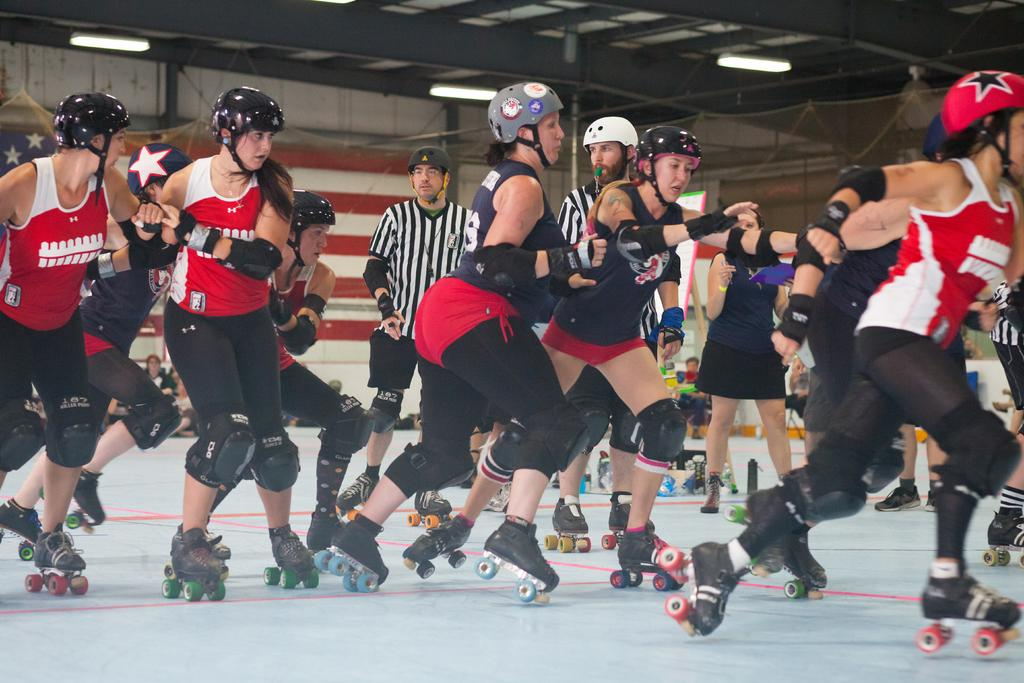What are the people in the image doing? The people in the image are skating. What type of shoes are the people wearing? The people are wearing skating shoes. Can you describe the flag in the image? There is a flag in the image, but its design or color cannot be determined from the provided facts. What can be seen in the background of the image? There are lights and other objects visible in the background of the image. What type of insurance policy do the people have for their skating shoes? There is no information about insurance policies for the skating shoes in the image. Can you tell me how many zebras are present in the image? There are no zebras present in the image; it features a group of people skating. 